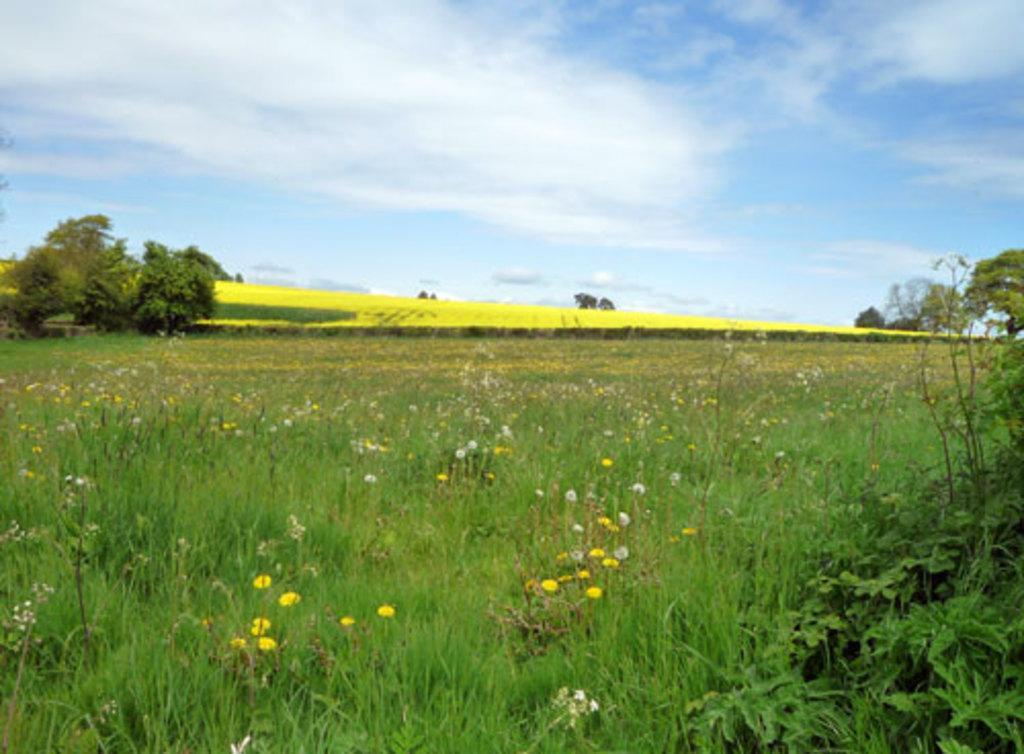Describe this image in one or two sentences. There are flowers in this grass in the down side and in the left side there are trees. At the top it's a blue sky. 